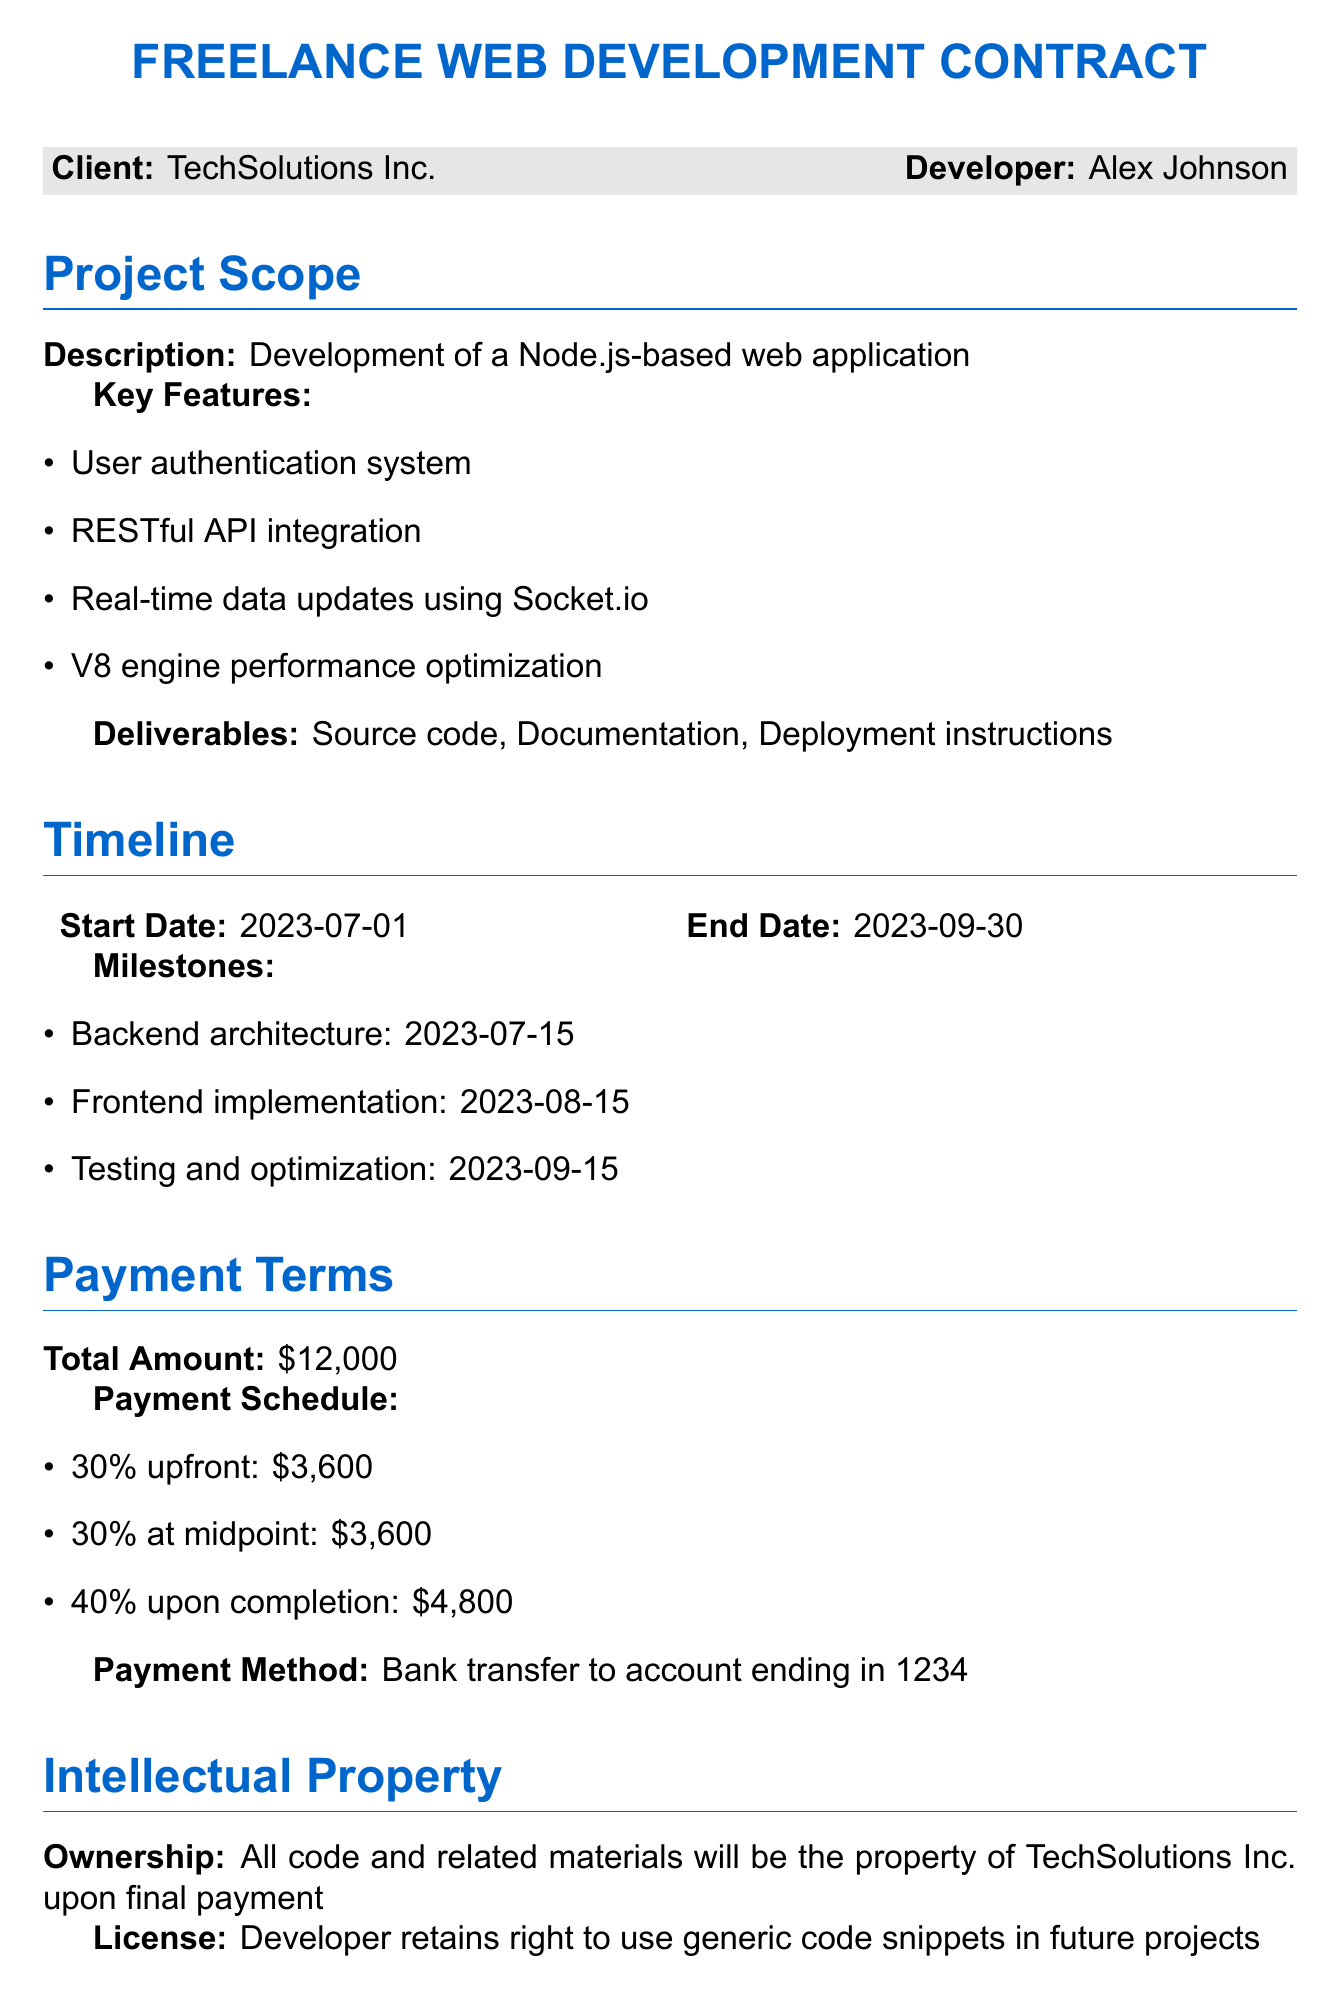What is the client’s name? The client is identified as TechSolutions Inc. in the document.
Answer: TechSolutions Inc What is the total amount for the project? The total payment amount is stated as twelve thousand dollars.
Answer: \$12,000 What does the payment schedule state for the upfront payment? The document specifies that the upfront payment is thirty percent of the total amount, which is indicated as three thousand six hundred dollars.
Answer: \$3,600 When does the testing and optimization milestone end? The document outlines that the testing and optimization milestone is due on September 15, 2023.
Answer: 2023-09-15 What is the notice period for contract termination? The document states that a fourteen-day written notice is required for termination by either party.
Answer: 14 days Which programming language is primarily used for development? The project scope indicates that a Node.js-based web application is being developed.
Answer: Node.js What is the last milestone outlined in the document? The final milestone mentioned in the document is testing and optimization.
Answer: Testing and optimization Who retains the rights to use generic code snippets? According to the intellectual property section, it is the developer who retains rights to use generic code snippets in future projects.
Answer: Developer What is the payment method specified in the contract? The document specifies that the payment method is a bank transfer to a certain account.
Answer: Bank transfer to account ending in 1234 